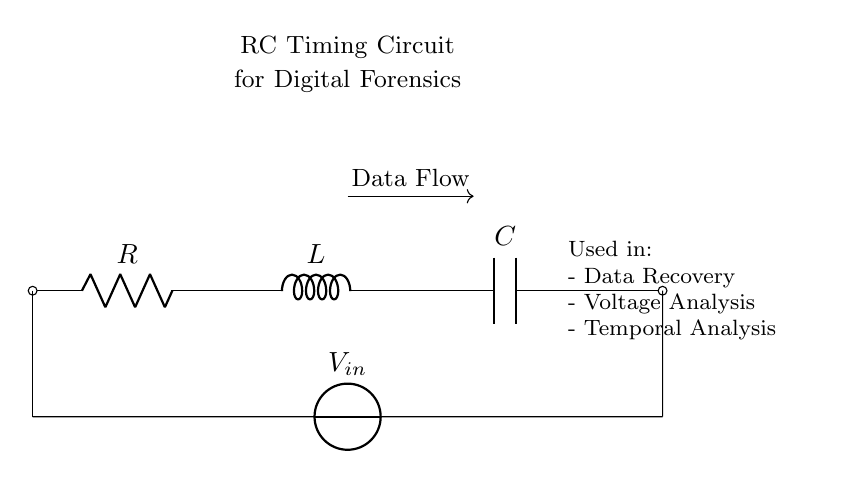What components are present in this circuit? The circuit includes a resistor, an inductor, and a capacitor, which are essential elements in an RC timing circuit. Each component is clearly labeled in the diagram.
Answer: Resistor, Inductor, Capacitor What is the input voltage represented in the circuit? The circuit diagram indicates the input voltage as V_in, which is a symbolic representation. While the exact value isn't specified, this is the primary voltage source driving the circuit.
Answer: V_in What role does the capacitor play in this circuit? The capacitor stores energy and regulates the timing of voltage changes within the circuit. In an RC timing circuit, it is responsible for charging and discharging based on the resistance and inductance, impacting data recovery timing.
Answer: Timing How does the arrangement of R, L, and C influence the behavior of the circuit? The configuration of these components determines the time constant of the circuit, affecting how quickly the circuit responds to changes in voltage. The interaction between resistance, inductance, and capacitance results in specific timing characteristics that are crucial for digital forensics analyses.
Answer: Time constant What is the intended application of this circuit as noted in the diagram? The circuit is used for data recovery, voltage analysis, and temporal analysis in digital forensics. This purpose is highlighted in the diagram and indicates its relevance in cybersecurity contexts.
Answer: Digital Forensics Tools 